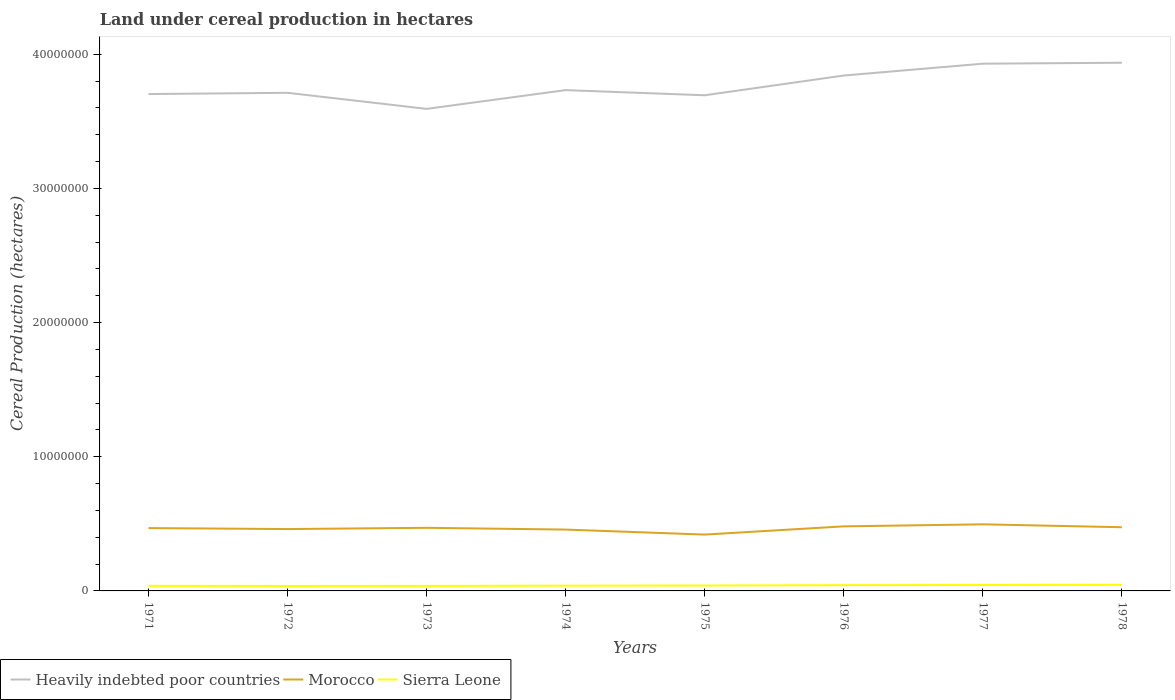Across all years, what is the maximum land under cereal production in Sierra Leone?
Make the answer very short. 3.71e+05. In which year was the land under cereal production in Heavily indebted poor countries maximum?
Offer a terse response. 1973. What is the total land under cereal production in Sierra Leone in the graph?
Your answer should be very brief. -10000. What is the difference between the highest and the second highest land under cereal production in Heavily indebted poor countries?
Provide a short and direct response. 3.44e+06. What is the difference between the highest and the lowest land under cereal production in Morocco?
Offer a very short reply. 5. How many lines are there?
Your answer should be very brief. 3. How many years are there in the graph?
Give a very brief answer. 8. What is the difference between two consecutive major ticks on the Y-axis?
Ensure brevity in your answer.  1.00e+07. Are the values on the major ticks of Y-axis written in scientific E-notation?
Provide a succinct answer. No. Does the graph contain grids?
Keep it short and to the point. No. How are the legend labels stacked?
Keep it short and to the point. Horizontal. What is the title of the graph?
Provide a short and direct response. Land under cereal production in hectares. Does "Bhutan" appear as one of the legend labels in the graph?
Your answer should be compact. No. What is the label or title of the Y-axis?
Offer a terse response. Cereal Production (hectares). What is the Cereal Production (hectares) of Heavily indebted poor countries in 1971?
Your response must be concise. 3.70e+07. What is the Cereal Production (hectares) of Morocco in 1971?
Make the answer very short. 4.68e+06. What is the Cereal Production (hectares) of Sierra Leone in 1971?
Provide a short and direct response. 3.78e+05. What is the Cereal Production (hectares) in Heavily indebted poor countries in 1972?
Provide a short and direct response. 3.71e+07. What is the Cereal Production (hectares) in Morocco in 1972?
Offer a terse response. 4.61e+06. What is the Cereal Production (hectares) of Sierra Leone in 1972?
Your response must be concise. 3.71e+05. What is the Cereal Production (hectares) in Heavily indebted poor countries in 1973?
Your response must be concise. 3.59e+07. What is the Cereal Production (hectares) in Morocco in 1973?
Keep it short and to the point. 4.70e+06. What is the Cereal Production (hectares) of Sierra Leone in 1973?
Offer a terse response. 3.74e+05. What is the Cereal Production (hectares) of Heavily indebted poor countries in 1974?
Offer a terse response. 3.73e+07. What is the Cereal Production (hectares) of Morocco in 1974?
Offer a very short reply. 4.57e+06. What is the Cereal Production (hectares) of Sierra Leone in 1974?
Your response must be concise. 3.94e+05. What is the Cereal Production (hectares) of Heavily indebted poor countries in 1975?
Your answer should be very brief. 3.69e+07. What is the Cereal Production (hectares) in Morocco in 1975?
Offer a very short reply. 4.20e+06. What is the Cereal Production (hectares) of Sierra Leone in 1975?
Provide a succinct answer. 4.04e+05. What is the Cereal Production (hectares) of Heavily indebted poor countries in 1976?
Your answer should be compact. 3.84e+07. What is the Cereal Production (hectares) of Morocco in 1976?
Ensure brevity in your answer.  4.81e+06. What is the Cereal Production (hectares) of Sierra Leone in 1976?
Ensure brevity in your answer.  4.30e+05. What is the Cereal Production (hectares) of Heavily indebted poor countries in 1977?
Provide a short and direct response. 3.93e+07. What is the Cereal Production (hectares) in Morocco in 1977?
Give a very brief answer. 4.96e+06. What is the Cereal Production (hectares) in Sierra Leone in 1977?
Make the answer very short. 4.40e+05. What is the Cereal Production (hectares) of Heavily indebted poor countries in 1978?
Your answer should be compact. 3.94e+07. What is the Cereal Production (hectares) of Morocco in 1978?
Make the answer very short. 4.75e+06. What is the Cereal Production (hectares) of Sierra Leone in 1978?
Your answer should be compact. 4.55e+05. Across all years, what is the maximum Cereal Production (hectares) in Heavily indebted poor countries?
Make the answer very short. 3.94e+07. Across all years, what is the maximum Cereal Production (hectares) in Morocco?
Offer a very short reply. 4.96e+06. Across all years, what is the maximum Cereal Production (hectares) of Sierra Leone?
Your response must be concise. 4.55e+05. Across all years, what is the minimum Cereal Production (hectares) in Heavily indebted poor countries?
Offer a terse response. 3.59e+07. Across all years, what is the minimum Cereal Production (hectares) in Morocco?
Give a very brief answer. 4.20e+06. Across all years, what is the minimum Cereal Production (hectares) in Sierra Leone?
Give a very brief answer. 3.71e+05. What is the total Cereal Production (hectares) in Heavily indebted poor countries in the graph?
Provide a short and direct response. 3.01e+08. What is the total Cereal Production (hectares) in Morocco in the graph?
Your answer should be compact. 3.73e+07. What is the total Cereal Production (hectares) of Sierra Leone in the graph?
Your answer should be very brief. 3.25e+06. What is the difference between the Cereal Production (hectares) of Heavily indebted poor countries in 1971 and that in 1972?
Offer a terse response. -9.20e+04. What is the difference between the Cereal Production (hectares) in Morocco in 1971 and that in 1972?
Keep it short and to the point. 7.42e+04. What is the difference between the Cereal Production (hectares) of Sierra Leone in 1971 and that in 1972?
Your answer should be very brief. 7800. What is the difference between the Cereal Production (hectares) of Heavily indebted poor countries in 1971 and that in 1973?
Provide a succinct answer. 1.10e+06. What is the difference between the Cereal Production (hectares) of Morocco in 1971 and that in 1973?
Your answer should be compact. -1.99e+04. What is the difference between the Cereal Production (hectares) in Sierra Leone in 1971 and that in 1973?
Offer a terse response. 4700. What is the difference between the Cereal Production (hectares) in Heavily indebted poor countries in 1971 and that in 1974?
Your answer should be compact. -2.92e+05. What is the difference between the Cereal Production (hectares) of Morocco in 1971 and that in 1974?
Offer a very short reply. 1.12e+05. What is the difference between the Cereal Production (hectares) in Sierra Leone in 1971 and that in 1974?
Offer a terse response. -1.51e+04. What is the difference between the Cereal Production (hectares) in Heavily indebted poor countries in 1971 and that in 1975?
Provide a short and direct response. 9.14e+04. What is the difference between the Cereal Production (hectares) of Morocco in 1971 and that in 1975?
Your response must be concise. 4.84e+05. What is the difference between the Cereal Production (hectares) of Sierra Leone in 1971 and that in 1975?
Provide a short and direct response. -2.51e+04. What is the difference between the Cereal Production (hectares) in Heavily indebted poor countries in 1971 and that in 1976?
Give a very brief answer. -1.38e+06. What is the difference between the Cereal Production (hectares) of Morocco in 1971 and that in 1976?
Your answer should be compact. -1.28e+05. What is the difference between the Cereal Production (hectares) of Sierra Leone in 1971 and that in 1976?
Your response must be concise. -5.14e+04. What is the difference between the Cereal Production (hectares) in Heavily indebted poor countries in 1971 and that in 1977?
Ensure brevity in your answer.  -2.26e+06. What is the difference between the Cereal Production (hectares) of Morocco in 1971 and that in 1977?
Ensure brevity in your answer.  -2.79e+05. What is the difference between the Cereal Production (hectares) of Sierra Leone in 1971 and that in 1977?
Your answer should be very brief. -6.20e+04. What is the difference between the Cereal Production (hectares) of Heavily indebted poor countries in 1971 and that in 1978?
Ensure brevity in your answer.  -2.33e+06. What is the difference between the Cereal Production (hectares) of Morocco in 1971 and that in 1978?
Offer a very short reply. -6.35e+04. What is the difference between the Cereal Production (hectares) in Sierra Leone in 1971 and that in 1978?
Give a very brief answer. -7.70e+04. What is the difference between the Cereal Production (hectares) in Heavily indebted poor countries in 1972 and that in 1973?
Keep it short and to the point. 1.20e+06. What is the difference between the Cereal Production (hectares) of Morocco in 1972 and that in 1973?
Provide a short and direct response. -9.41e+04. What is the difference between the Cereal Production (hectares) in Sierra Leone in 1972 and that in 1973?
Keep it short and to the point. -3100. What is the difference between the Cereal Production (hectares) in Heavily indebted poor countries in 1972 and that in 1974?
Make the answer very short. -2.00e+05. What is the difference between the Cereal Production (hectares) of Morocco in 1972 and that in 1974?
Make the answer very short. 3.81e+04. What is the difference between the Cereal Production (hectares) in Sierra Leone in 1972 and that in 1974?
Provide a succinct answer. -2.29e+04. What is the difference between the Cereal Production (hectares) of Heavily indebted poor countries in 1972 and that in 1975?
Your answer should be very brief. 1.83e+05. What is the difference between the Cereal Production (hectares) in Morocco in 1972 and that in 1975?
Keep it short and to the point. 4.10e+05. What is the difference between the Cereal Production (hectares) in Sierra Leone in 1972 and that in 1975?
Give a very brief answer. -3.29e+04. What is the difference between the Cereal Production (hectares) in Heavily indebted poor countries in 1972 and that in 1976?
Keep it short and to the point. -1.29e+06. What is the difference between the Cereal Production (hectares) in Morocco in 1972 and that in 1976?
Ensure brevity in your answer.  -2.02e+05. What is the difference between the Cereal Production (hectares) of Sierra Leone in 1972 and that in 1976?
Offer a very short reply. -5.92e+04. What is the difference between the Cereal Production (hectares) in Heavily indebted poor countries in 1972 and that in 1977?
Offer a very short reply. -2.17e+06. What is the difference between the Cereal Production (hectares) in Morocco in 1972 and that in 1977?
Your answer should be very brief. -3.53e+05. What is the difference between the Cereal Production (hectares) of Sierra Leone in 1972 and that in 1977?
Provide a short and direct response. -6.98e+04. What is the difference between the Cereal Production (hectares) in Heavily indebted poor countries in 1972 and that in 1978?
Your answer should be compact. -2.24e+06. What is the difference between the Cereal Production (hectares) of Morocco in 1972 and that in 1978?
Offer a very short reply. -1.38e+05. What is the difference between the Cereal Production (hectares) of Sierra Leone in 1972 and that in 1978?
Provide a short and direct response. -8.48e+04. What is the difference between the Cereal Production (hectares) of Heavily indebted poor countries in 1973 and that in 1974?
Make the answer very short. -1.40e+06. What is the difference between the Cereal Production (hectares) in Morocco in 1973 and that in 1974?
Your response must be concise. 1.32e+05. What is the difference between the Cereal Production (hectares) in Sierra Leone in 1973 and that in 1974?
Offer a very short reply. -1.98e+04. What is the difference between the Cereal Production (hectares) in Heavily indebted poor countries in 1973 and that in 1975?
Provide a succinct answer. -1.01e+06. What is the difference between the Cereal Production (hectares) in Morocco in 1973 and that in 1975?
Keep it short and to the point. 5.04e+05. What is the difference between the Cereal Production (hectares) in Sierra Leone in 1973 and that in 1975?
Make the answer very short. -2.98e+04. What is the difference between the Cereal Production (hectares) of Heavily indebted poor countries in 1973 and that in 1976?
Offer a very short reply. -2.48e+06. What is the difference between the Cereal Production (hectares) of Morocco in 1973 and that in 1976?
Provide a succinct answer. -1.08e+05. What is the difference between the Cereal Production (hectares) of Sierra Leone in 1973 and that in 1976?
Give a very brief answer. -5.61e+04. What is the difference between the Cereal Production (hectares) in Heavily indebted poor countries in 1973 and that in 1977?
Your response must be concise. -3.37e+06. What is the difference between the Cereal Production (hectares) in Morocco in 1973 and that in 1977?
Keep it short and to the point. -2.59e+05. What is the difference between the Cereal Production (hectares) of Sierra Leone in 1973 and that in 1977?
Offer a very short reply. -6.67e+04. What is the difference between the Cereal Production (hectares) in Heavily indebted poor countries in 1973 and that in 1978?
Provide a succinct answer. -3.44e+06. What is the difference between the Cereal Production (hectares) of Morocco in 1973 and that in 1978?
Your answer should be compact. -4.36e+04. What is the difference between the Cereal Production (hectares) of Sierra Leone in 1973 and that in 1978?
Your response must be concise. -8.17e+04. What is the difference between the Cereal Production (hectares) in Heavily indebted poor countries in 1974 and that in 1975?
Offer a very short reply. 3.83e+05. What is the difference between the Cereal Production (hectares) of Morocco in 1974 and that in 1975?
Your answer should be compact. 3.72e+05. What is the difference between the Cereal Production (hectares) in Sierra Leone in 1974 and that in 1975?
Your response must be concise. -10000. What is the difference between the Cereal Production (hectares) in Heavily indebted poor countries in 1974 and that in 1976?
Keep it short and to the point. -1.09e+06. What is the difference between the Cereal Production (hectares) of Morocco in 1974 and that in 1976?
Your answer should be very brief. -2.40e+05. What is the difference between the Cereal Production (hectares) of Sierra Leone in 1974 and that in 1976?
Your answer should be compact. -3.63e+04. What is the difference between the Cereal Production (hectares) of Heavily indebted poor countries in 1974 and that in 1977?
Your response must be concise. -1.97e+06. What is the difference between the Cereal Production (hectares) in Morocco in 1974 and that in 1977?
Ensure brevity in your answer.  -3.91e+05. What is the difference between the Cereal Production (hectares) of Sierra Leone in 1974 and that in 1977?
Your response must be concise. -4.69e+04. What is the difference between the Cereal Production (hectares) in Heavily indebted poor countries in 1974 and that in 1978?
Provide a short and direct response. -2.04e+06. What is the difference between the Cereal Production (hectares) in Morocco in 1974 and that in 1978?
Your answer should be very brief. -1.76e+05. What is the difference between the Cereal Production (hectares) of Sierra Leone in 1974 and that in 1978?
Provide a short and direct response. -6.19e+04. What is the difference between the Cereal Production (hectares) in Heavily indebted poor countries in 1975 and that in 1976?
Provide a short and direct response. -1.47e+06. What is the difference between the Cereal Production (hectares) of Morocco in 1975 and that in 1976?
Your response must be concise. -6.12e+05. What is the difference between the Cereal Production (hectares) of Sierra Leone in 1975 and that in 1976?
Provide a succinct answer. -2.63e+04. What is the difference between the Cereal Production (hectares) of Heavily indebted poor countries in 1975 and that in 1977?
Your answer should be very brief. -2.35e+06. What is the difference between the Cereal Production (hectares) in Morocco in 1975 and that in 1977?
Provide a succinct answer. -7.63e+05. What is the difference between the Cereal Production (hectares) in Sierra Leone in 1975 and that in 1977?
Your answer should be very brief. -3.69e+04. What is the difference between the Cereal Production (hectares) in Heavily indebted poor countries in 1975 and that in 1978?
Provide a succinct answer. -2.42e+06. What is the difference between the Cereal Production (hectares) in Morocco in 1975 and that in 1978?
Your response must be concise. -5.48e+05. What is the difference between the Cereal Production (hectares) in Sierra Leone in 1975 and that in 1978?
Provide a short and direct response. -5.19e+04. What is the difference between the Cereal Production (hectares) in Heavily indebted poor countries in 1976 and that in 1977?
Give a very brief answer. -8.82e+05. What is the difference between the Cereal Production (hectares) in Morocco in 1976 and that in 1977?
Offer a terse response. -1.51e+05. What is the difference between the Cereal Production (hectares) of Sierra Leone in 1976 and that in 1977?
Your response must be concise. -1.06e+04. What is the difference between the Cereal Production (hectares) of Heavily indebted poor countries in 1976 and that in 1978?
Keep it short and to the point. -9.54e+05. What is the difference between the Cereal Production (hectares) in Morocco in 1976 and that in 1978?
Provide a succinct answer. 6.41e+04. What is the difference between the Cereal Production (hectares) of Sierra Leone in 1976 and that in 1978?
Provide a short and direct response. -2.56e+04. What is the difference between the Cereal Production (hectares) in Heavily indebted poor countries in 1977 and that in 1978?
Your response must be concise. -7.14e+04. What is the difference between the Cereal Production (hectares) in Morocco in 1977 and that in 1978?
Your answer should be very brief. 2.16e+05. What is the difference between the Cereal Production (hectares) of Sierra Leone in 1977 and that in 1978?
Offer a terse response. -1.50e+04. What is the difference between the Cereal Production (hectares) in Heavily indebted poor countries in 1971 and the Cereal Production (hectares) in Morocco in 1972?
Provide a short and direct response. 3.24e+07. What is the difference between the Cereal Production (hectares) in Heavily indebted poor countries in 1971 and the Cereal Production (hectares) in Sierra Leone in 1972?
Your answer should be very brief. 3.67e+07. What is the difference between the Cereal Production (hectares) in Morocco in 1971 and the Cereal Production (hectares) in Sierra Leone in 1972?
Your answer should be very brief. 4.31e+06. What is the difference between the Cereal Production (hectares) in Heavily indebted poor countries in 1971 and the Cereal Production (hectares) in Morocco in 1973?
Offer a very short reply. 3.23e+07. What is the difference between the Cereal Production (hectares) of Heavily indebted poor countries in 1971 and the Cereal Production (hectares) of Sierra Leone in 1973?
Give a very brief answer. 3.67e+07. What is the difference between the Cereal Production (hectares) of Morocco in 1971 and the Cereal Production (hectares) of Sierra Leone in 1973?
Provide a short and direct response. 4.31e+06. What is the difference between the Cereal Production (hectares) of Heavily indebted poor countries in 1971 and the Cereal Production (hectares) of Morocco in 1974?
Your answer should be compact. 3.25e+07. What is the difference between the Cereal Production (hectares) in Heavily indebted poor countries in 1971 and the Cereal Production (hectares) in Sierra Leone in 1974?
Keep it short and to the point. 3.66e+07. What is the difference between the Cereal Production (hectares) in Morocco in 1971 and the Cereal Production (hectares) in Sierra Leone in 1974?
Make the answer very short. 4.29e+06. What is the difference between the Cereal Production (hectares) in Heavily indebted poor countries in 1971 and the Cereal Production (hectares) in Morocco in 1975?
Ensure brevity in your answer.  3.28e+07. What is the difference between the Cereal Production (hectares) in Heavily indebted poor countries in 1971 and the Cereal Production (hectares) in Sierra Leone in 1975?
Your answer should be compact. 3.66e+07. What is the difference between the Cereal Production (hectares) in Morocco in 1971 and the Cereal Production (hectares) in Sierra Leone in 1975?
Provide a short and direct response. 4.28e+06. What is the difference between the Cereal Production (hectares) of Heavily indebted poor countries in 1971 and the Cereal Production (hectares) of Morocco in 1976?
Offer a very short reply. 3.22e+07. What is the difference between the Cereal Production (hectares) in Heavily indebted poor countries in 1971 and the Cereal Production (hectares) in Sierra Leone in 1976?
Provide a succinct answer. 3.66e+07. What is the difference between the Cereal Production (hectares) of Morocco in 1971 and the Cereal Production (hectares) of Sierra Leone in 1976?
Ensure brevity in your answer.  4.25e+06. What is the difference between the Cereal Production (hectares) of Heavily indebted poor countries in 1971 and the Cereal Production (hectares) of Morocco in 1977?
Offer a very short reply. 3.21e+07. What is the difference between the Cereal Production (hectares) in Heavily indebted poor countries in 1971 and the Cereal Production (hectares) in Sierra Leone in 1977?
Ensure brevity in your answer.  3.66e+07. What is the difference between the Cereal Production (hectares) in Morocco in 1971 and the Cereal Production (hectares) in Sierra Leone in 1977?
Give a very brief answer. 4.24e+06. What is the difference between the Cereal Production (hectares) in Heavily indebted poor countries in 1971 and the Cereal Production (hectares) in Morocco in 1978?
Give a very brief answer. 3.23e+07. What is the difference between the Cereal Production (hectares) of Heavily indebted poor countries in 1971 and the Cereal Production (hectares) of Sierra Leone in 1978?
Ensure brevity in your answer.  3.66e+07. What is the difference between the Cereal Production (hectares) in Morocco in 1971 and the Cereal Production (hectares) in Sierra Leone in 1978?
Provide a short and direct response. 4.23e+06. What is the difference between the Cereal Production (hectares) in Heavily indebted poor countries in 1972 and the Cereal Production (hectares) in Morocco in 1973?
Provide a succinct answer. 3.24e+07. What is the difference between the Cereal Production (hectares) of Heavily indebted poor countries in 1972 and the Cereal Production (hectares) of Sierra Leone in 1973?
Give a very brief answer. 3.68e+07. What is the difference between the Cereal Production (hectares) in Morocco in 1972 and the Cereal Production (hectares) in Sierra Leone in 1973?
Your answer should be compact. 4.24e+06. What is the difference between the Cereal Production (hectares) of Heavily indebted poor countries in 1972 and the Cereal Production (hectares) of Morocco in 1974?
Offer a very short reply. 3.26e+07. What is the difference between the Cereal Production (hectares) of Heavily indebted poor countries in 1972 and the Cereal Production (hectares) of Sierra Leone in 1974?
Ensure brevity in your answer.  3.67e+07. What is the difference between the Cereal Production (hectares) in Morocco in 1972 and the Cereal Production (hectares) in Sierra Leone in 1974?
Offer a terse response. 4.22e+06. What is the difference between the Cereal Production (hectares) of Heavily indebted poor countries in 1972 and the Cereal Production (hectares) of Morocco in 1975?
Your answer should be compact. 3.29e+07. What is the difference between the Cereal Production (hectares) in Heavily indebted poor countries in 1972 and the Cereal Production (hectares) in Sierra Leone in 1975?
Offer a terse response. 3.67e+07. What is the difference between the Cereal Production (hectares) in Morocco in 1972 and the Cereal Production (hectares) in Sierra Leone in 1975?
Your response must be concise. 4.21e+06. What is the difference between the Cereal Production (hectares) of Heavily indebted poor countries in 1972 and the Cereal Production (hectares) of Morocco in 1976?
Offer a very short reply. 3.23e+07. What is the difference between the Cereal Production (hectares) of Heavily indebted poor countries in 1972 and the Cereal Production (hectares) of Sierra Leone in 1976?
Keep it short and to the point. 3.67e+07. What is the difference between the Cereal Production (hectares) of Morocco in 1972 and the Cereal Production (hectares) of Sierra Leone in 1976?
Keep it short and to the point. 4.18e+06. What is the difference between the Cereal Production (hectares) of Heavily indebted poor countries in 1972 and the Cereal Production (hectares) of Morocco in 1977?
Your answer should be very brief. 3.22e+07. What is the difference between the Cereal Production (hectares) in Heavily indebted poor countries in 1972 and the Cereal Production (hectares) in Sierra Leone in 1977?
Ensure brevity in your answer.  3.67e+07. What is the difference between the Cereal Production (hectares) in Morocco in 1972 and the Cereal Production (hectares) in Sierra Leone in 1977?
Offer a terse response. 4.17e+06. What is the difference between the Cereal Production (hectares) of Heavily indebted poor countries in 1972 and the Cereal Production (hectares) of Morocco in 1978?
Your answer should be very brief. 3.24e+07. What is the difference between the Cereal Production (hectares) in Heavily indebted poor countries in 1972 and the Cereal Production (hectares) in Sierra Leone in 1978?
Provide a succinct answer. 3.67e+07. What is the difference between the Cereal Production (hectares) of Morocco in 1972 and the Cereal Production (hectares) of Sierra Leone in 1978?
Offer a very short reply. 4.15e+06. What is the difference between the Cereal Production (hectares) of Heavily indebted poor countries in 1973 and the Cereal Production (hectares) of Morocco in 1974?
Make the answer very short. 3.14e+07. What is the difference between the Cereal Production (hectares) in Heavily indebted poor countries in 1973 and the Cereal Production (hectares) in Sierra Leone in 1974?
Give a very brief answer. 3.55e+07. What is the difference between the Cereal Production (hectares) of Morocco in 1973 and the Cereal Production (hectares) of Sierra Leone in 1974?
Keep it short and to the point. 4.31e+06. What is the difference between the Cereal Production (hectares) in Heavily indebted poor countries in 1973 and the Cereal Production (hectares) in Morocco in 1975?
Provide a succinct answer. 3.17e+07. What is the difference between the Cereal Production (hectares) of Heavily indebted poor countries in 1973 and the Cereal Production (hectares) of Sierra Leone in 1975?
Offer a terse response. 3.55e+07. What is the difference between the Cereal Production (hectares) in Morocco in 1973 and the Cereal Production (hectares) in Sierra Leone in 1975?
Keep it short and to the point. 4.30e+06. What is the difference between the Cereal Production (hectares) in Heavily indebted poor countries in 1973 and the Cereal Production (hectares) in Morocco in 1976?
Your answer should be compact. 3.11e+07. What is the difference between the Cereal Production (hectares) of Heavily indebted poor countries in 1973 and the Cereal Production (hectares) of Sierra Leone in 1976?
Keep it short and to the point. 3.55e+07. What is the difference between the Cereal Production (hectares) in Morocco in 1973 and the Cereal Production (hectares) in Sierra Leone in 1976?
Provide a short and direct response. 4.27e+06. What is the difference between the Cereal Production (hectares) in Heavily indebted poor countries in 1973 and the Cereal Production (hectares) in Morocco in 1977?
Keep it short and to the point. 3.10e+07. What is the difference between the Cereal Production (hectares) of Heavily indebted poor countries in 1973 and the Cereal Production (hectares) of Sierra Leone in 1977?
Your answer should be compact. 3.55e+07. What is the difference between the Cereal Production (hectares) in Morocco in 1973 and the Cereal Production (hectares) in Sierra Leone in 1977?
Ensure brevity in your answer.  4.26e+06. What is the difference between the Cereal Production (hectares) of Heavily indebted poor countries in 1973 and the Cereal Production (hectares) of Morocco in 1978?
Provide a short and direct response. 3.12e+07. What is the difference between the Cereal Production (hectares) of Heavily indebted poor countries in 1973 and the Cereal Production (hectares) of Sierra Leone in 1978?
Ensure brevity in your answer.  3.55e+07. What is the difference between the Cereal Production (hectares) of Morocco in 1973 and the Cereal Production (hectares) of Sierra Leone in 1978?
Offer a very short reply. 4.25e+06. What is the difference between the Cereal Production (hectares) of Heavily indebted poor countries in 1974 and the Cereal Production (hectares) of Morocco in 1975?
Your answer should be compact. 3.31e+07. What is the difference between the Cereal Production (hectares) of Heavily indebted poor countries in 1974 and the Cereal Production (hectares) of Sierra Leone in 1975?
Provide a short and direct response. 3.69e+07. What is the difference between the Cereal Production (hectares) of Morocco in 1974 and the Cereal Production (hectares) of Sierra Leone in 1975?
Your response must be concise. 4.17e+06. What is the difference between the Cereal Production (hectares) of Heavily indebted poor countries in 1974 and the Cereal Production (hectares) of Morocco in 1976?
Your answer should be compact. 3.25e+07. What is the difference between the Cereal Production (hectares) of Heavily indebted poor countries in 1974 and the Cereal Production (hectares) of Sierra Leone in 1976?
Provide a short and direct response. 3.69e+07. What is the difference between the Cereal Production (hectares) of Morocco in 1974 and the Cereal Production (hectares) of Sierra Leone in 1976?
Your answer should be compact. 4.14e+06. What is the difference between the Cereal Production (hectares) of Heavily indebted poor countries in 1974 and the Cereal Production (hectares) of Morocco in 1977?
Ensure brevity in your answer.  3.24e+07. What is the difference between the Cereal Production (hectares) of Heavily indebted poor countries in 1974 and the Cereal Production (hectares) of Sierra Leone in 1977?
Provide a succinct answer. 3.69e+07. What is the difference between the Cereal Production (hectares) of Morocco in 1974 and the Cereal Production (hectares) of Sierra Leone in 1977?
Offer a very short reply. 4.13e+06. What is the difference between the Cereal Production (hectares) in Heavily indebted poor countries in 1974 and the Cereal Production (hectares) in Morocco in 1978?
Provide a succinct answer. 3.26e+07. What is the difference between the Cereal Production (hectares) in Heavily indebted poor countries in 1974 and the Cereal Production (hectares) in Sierra Leone in 1978?
Provide a short and direct response. 3.69e+07. What is the difference between the Cereal Production (hectares) of Morocco in 1974 and the Cereal Production (hectares) of Sierra Leone in 1978?
Give a very brief answer. 4.12e+06. What is the difference between the Cereal Production (hectares) in Heavily indebted poor countries in 1975 and the Cereal Production (hectares) in Morocco in 1976?
Your answer should be compact. 3.21e+07. What is the difference between the Cereal Production (hectares) of Heavily indebted poor countries in 1975 and the Cereal Production (hectares) of Sierra Leone in 1976?
Offer a very short reply. 3.65e+07. What is the difference between the Cereal Production (hectares) of Morocco in 1975 and the Cereal Production (hectares) of Sierra Leone in 1976?
Make the answer very short. 3.77e+06. What is the difference between the Cereal Production (hectares) of Heavily indebted poor countries in 1975 and the Cereal Production (hectares) of Morocco in 1977?
Provide a short and direct response. 3.20e+07. What is the difference between the Cereal Production (hectares) of Heavily indebted poor countries in 1975 and the Cereal Production (hectares) of Sierra Leone in 1977?
Give a very brief answer. 3.65e+07. What is the difference between the Cereal Production (hectares) of Morocco in 1975 and the Cereal Production (hectares) of Sierra Leone in 1977?
Your answer should be very brief. 3.76e+06. What is the difference between the Cereal Production (hectares) in Heavily indebted poor countries in 1975 and the Cereal Production (hectares) in Morocco in 1978?
Ensure brevity in your answer.  3.22e+07. What is the difference between the Cereal Production (hectares) of Heavily indebted poor countries in 1975 and the Cereal Production (hectares) of Sierra Leone in 1978?
Offer a very short reply. 3.65e+07. What is the difference between the Cereal Production (hectares) of Morocco in 1975 and the Cereal Production (hectares) of Sierra Leone in 1978?
Provide a short and direct response. 3.74e+06. What is the difference between the Cereal Production (hectares) in Heavily indebted poor countries in 1976 and the Cereal Production (hectares) in Morocco in 1977?
Your answer should be very brief. 3.35e+07. What is the difference between the Cereal Production (hectares) of Heavily indebted poor countries in 1976 and the Cereal Production (hectares) of Sierra Leone in 1977?
Offer a terse response. 3.80e+07. What is the difference between the Cereal Production (hectares) of Morocco in 1976 and the Cereal Production (hectares) of Sierra Leone in 1977?
Offer a very short reply. 4.37e+06. What is the difference between the Cereal Production (hectares) of Heavily indebted poor countries in 1976 and the Cereal Production (hectares) of Morocco in 1978?
Offer a terse response. 3.37e+07. What is the difference between the Cereal Production (hectares) in Heavily indebted poor countries in 1976 and the Cereal Production (hectares) in Sierra Leone in 1978?
Ensure brevity in your answer.  3.80e+07. What is the difference between the Cereal Production (hectares) in Morocco in 1976 and the Cereal Production (hectares) in Sierra Leone in 1978?
Provide a short and direct response. 4.36e+06. What is the difference between the Cereal Production (hectares) in Heavily indebted poor countries in 1977 and the Cereal Production (hectares) in Morocco in 1978?
Your answer should be compact. 3.45e+07. What is the difference between the Cereal Production (hectares) of Heavily indebted poor countries in 1977 and the Cereal Production (hectares) of Sierra Leone in 1978?
Provide a succinct answer. 3.88e+07. What is the difference between the Cereal Production (hectares) of Morocco in 1977 and the Cereal Production (hectares) of Sierra Leone in 1978?
Give a very brief answer. 4.51e+06. What is the average Cereal Production (hectares) of Heavily indebted poor countries per year?
Your answer should be compact. 3.77e+07. What is the average Cereal Production (hectares) in Morocco per year?
Your answer should be compact. 4.66e+06. What is the average Cereal Production (hectares) in Sierra Leone per year?
Give a very brief answer. 4.06e+05. In the year 1971, what is the difference between the Cereal Production (hectares) in Heavily indebted poor countries and Cereal Production (hectares) in Morocco?
Your answer should be compact. 3.24e+07. In the year 1971, what is the difference between the Cereal Production (hectares) in Heavily indebted poor countries and Cereal Production (hectares) in Sierra Leone?
Offer a very short reply. 3.67e+07. In the year 1971, what is the difference between the Cereal Production (hectares) of Morocco and Cereal Production (hectares) of Sierra Leone?
Your answer should be very brief. 4.31e+06. In the year 1972, what is the difference between the Cereal Production (hectares) of Heavily indebted poor countries and Cereal Production (hectares) of Morocco?
Offer a very short reply. 3.25e+07. In the year 1972, what is the difference between the Cereal Production (hectares) of Heavily indebted poor countries and Cereal Production (hectares) of Sierra Leone?
Provide a short and direct response. 3.68e+07. In the year 1972, what is the difference between the Cereal Production (hectares) of Morocco and Cereal Production (hectares) of Sierra Leone?
Your response must be concise. 4.24e+06. In the year 1973, what is the difference between the Cereal Production (hectares) in Heavily indebted poor countries and Cereal Production (hectares) in Morocco?
Offer a terse response. 3.12e+07. In the year 1973, what is the difference between the Cereal Production (hectares) of Heavily indebted poor countries and Cereal Production (hectares) of Sierra Leone?
Offer a very short reply. 3.56e+07. In the year 1973, what is the difference between the Cereal Production (hectares) in Morocco and Cereal Production (hectares) in Sierra Leone?
Offer a terse response. 4.33e+06. In the year 1974, what is the difference between the Cereal Production (hectares) of Heavily indebted poor countries and Cereal Production (hectares) of Morocco?
Your answer should be compact. 3.28e+07. In the year 1974, what is the difference between the Cereal Production (hectares) in Heavily indebted poor countries and Cereal Production (hectares) in Sierra Leone?
Offer a very short reply. 3.69e+07. In the year 1974, what is the difference between the Cereal Production (hectares) of Morocco and Cereal Production (hectares) of Sierra Leone?
Your answer should be compact. 4.18e+06. In the year 1975, what is the difference between the Cereal Production (hectares) in Heavily indebted poor countries and Cereal Production (hectares) in Morocco?
Ensure brevity in your answer.  3.27e+07. In the year 1975, what is the difference between the Cereal Production (hectares) in Heavily indebted poor countries and Cereal Production (hectares) in Sierra Leone?
Make the answer very short. 3.65e+07. In the year 1975, what is the difference between the Cereal Production (hectares) of Morocco and Cereal Production (hectares) of Sierra Leone?
Provide a short and direct response. 3.80e+06. In the year 1976, what is the difference between the Cereal Production (hectares) in Heavily indebted poor countries and Cereal Production (hectares) in Morocco?
Your answer should be very brief. 3.36e+07. In the year 1976, what is the difference between the Cereal Production (hectares) in Heavily indebted poor countries and Cereal Production (hectares) in Sierra Leone?
Offer a very short reply. 3.80e+07. In the year 1976, what is the difference between the Cereal Production (hectares) of Morocco and Cereal Production (hectares) of Sierra Leone?
Offer a terse response. 4.38e+06. In the year 1977, what is the difference between the Cereal Production (hectares) of Heavily indebted poor countries and Cereal Production (hectares) of Morocco?
Offer a very short reply. 3.43e+07. In the year 1977, what is the difference between the Cereal Production (hectares) in Heavily indebted poor countries and Cereal Production (hectares) in Sierra Leone?
Make the answer very short. 3.89e+07. In the year 1977, what is the difference between the Cereal Production (hectares) in Morocco and Cereal Production (hectares) in Sierra Leone?
Provide a short and direct response. 4.52e+06. In the year 1978, what is the difference between the Cereal Production (hectares) in Heavily indebted poor countries and Cereal Production (hectares) in Morocco?
Your response must be concise. 3.46e+07. In the year 1978, what is the difference between the Cereal Production (hectares) in Heavily indebted poor countries and Cereal Production (hectares) in Sierra Leone?
Keep it short and to the point. 3.89e+07. In the year 1978, what is the difference between the Cereal Production (hectares) of Morocco and Cereal Production (hectares) of Sierra Leone?
Your answer should be compact. 4.29e+06. What is the ratio of the Cereal Production (hectares) in Morocco in 1971 to that in 1972?
Your answer should be very brief. 1.02. What is the ratio of the Cereal Production (hectares) of Sierra Leone in 1971 to that in 1972?
Keep it short and to the point. 1.02. What is the ratio of the Cereal Production (hectares) of Heavily indebted poor countries in 1971 to that in 1973?
Provide a succinct answer. 1.03. What is the ratio of the Cereal Production (hectares) of Sierra Leone in 1971 to that in 1973?
Offer a terse response. 1.01. What is the ratio of the Cereal Production (hectares) of Heavily indebted poor countries in 1971 to that in 1974?
Ensure brevity in your answer.  0.99. What is the ratio of the Cereal Production (hectares) in Morocco in 1971 to that in 1974?
Offer a very short reply. 1.02. What is the ratio of the Cereal Production (hectares) in Sierra Leone in 1971 to that in 1974?
Keep it short and to the point. 0.96. What is the ratio of the Cereal Production (hectares) in Morocco in 1971 to that in 1975?
Offer a very short reply. 1.12. What is the ratio of the Cereal Production (hectares) of Sierra Leone in 1971 to that in 1975?
Make the answer very short. 0.94. What is the ratio of the Cereal Production (hectares) in Heavily indebted poor countries in 1971 to that in 1976?
Offer a very short reply. 0.96. What is the ratio of the Cereal Production (hectares) of Morocco in 1971 to that in 1976?
Offer a terse response. 0.97. What is the ratio of the Cereal Production (hectares) in Sierra Leone in 1971 to that in 1976?
Offer a very short reply. 0.88. What is the ratio of the Cereal Production (hectares) of Heavily indebted poor countries in 1971 to that in 1977?
Provide a succinct answer. 0.94. What is the ratio of the Cereal Production (hectares) of Morocco in 1971 to that in 1977?
Give a very brief answer. 0.94. What is the ratio of the Cereal Production (hectares) in Sierra Leone in 1971 to that in 1977?
Make the answer very short. 0.86. What is the ratio of the Cereal Production (hectares) of Heavily indebted poor countries in 1971 to that in 1978?
Ensure brevity in your answer.  0.94. What is the ratio of the Cereal Production (hectares) in Morocco in 1971 to that in 1978?
Offer a very short reply. 0.99. What is the ratio of the Cereal Production (hectares) of Sierra Leone in 1971 to that in 1978?
Your answer should be very brief. 0.83. What is the ratio of the Cereal Production (hectares) in Heavily indebted poor countries in 1972 to that in 1973?
Your answer should be very brief. 1.03. What is the ratio of the Cereal Production (hectares) in Morocco in 1972 to that in 1974?
Offer a very short reply. 1.01. What is the ratio of the Cereal Production (hectares) in Sierra Leone in 1972 to that in 1974?
Offer a very short reply. 0.94. What is the ratio of the Cereal Production (hectares) of Heavily indebted poor countries in 1972 to that in 1975?
Keep it short and to the point. 1. What is the ratio of the Cereal Production (hectares) in Morocco in 1972 to that in 1975?
Make the answer very short. 1.1. What is the ratio of the Cereal Production (hectares) of Sierra Leone in 1972 to that in 1975?
Provide a succinct answer. 0.92. What is the ratio of the Cereal Production (hectares) in Heavily indebted poor countries in 1972 to that in 1976?
Make the answer very short. 0.97. What is the ratio of the Cereal Production (hectares) in Morocco in 1972 to that in 1976?
Your answer should be very brief. 0.96. What is the ratio of the Cereal Production (hectares) of Sierra Leone in 1972 to that in 1976?
Keep it short and to the point. 0.86. What is the ratio of the Cereal Production (hectares) of Heavily indebted poor countries in 1972 to that in 1977?
Ensure brevity in your answer.  0.94. What is the ratio of the Cereal Production (hectares) in Morocco in 1972 to that in 1977?
Your answer should be compact. 0.93. What is the ratio of the Cereal Production (hectares) of Sierra Leone in 1972 to that in 1977?
Offer a terse response. 0.84. What is the ratio of the Cereal Production (hectares) in Heavily indebted poor countries in 1972 to that in 1978?
Make the answer very short. 0.94. What is the ratio of the Cereal Production (hectares) of Sierra Leone in 1972 to that in 1978?
Ensure brevity in your answer.  0.81. What is the ratio of the Cereal Production (hectares) of Heavily indebted poor countries in 1973 to that in 1974?
Your answer should be very brief. 0.96. What is the ratio of the Cereal Production (hectares) in Morocco in 1973 to that in 1974?
Your response must be concise. 1.03. What is the ratio of the Cereal Production (hectares) of Sierra Leone in 1973 to that in 1974?
Offer a terse response. 0.95. What is the ratio of the Cereal Production (hectares) in Heavily indebted poor countries in 1973 to that in 1975?
Provide a succinct answer. 0.97. What is the ratio of the Cereal Production (hectares) in Morocco in 1973 to that in 1975?
Your response must be concise. 1.12. What is the ratio of the Cereal Production (hectares) in Sierra Leone in 1973 to that in 1975?
Offer a terse response. 0.93. What is the ratio of the Cereal Production (hectares) in Heavily indebted poor countries in 1973 to that in 1976?
Give a very brief answer. 0.94. What is the ratio of the Cereal Production (hectares) in Morocco in 1973 to that in 1976?
Ensure brevity in your answer.  0.98. What is the ratio of the Cereal Production (hectares) in Sierra Leone in 1973 to that in 1976?
Keep it short and to the point. 0.87. What is the ratio of the Cereal Production (hectares) of Heavily indebted poor countries in 1973 to that in 1977?
Offer a very short reply. 0.91. What is the ratio of the Cereal Production (hectares) of Morocco in 1973 to that in 1977?
Provide a short and direct response. 0.95. What is the ratio of the Cereal Production (hectares) of Sierra Leone in 1973 to that in 1977?
Offer a terse response. 0.85. What is the ratio of the Cereal Production (hectares) of Heavily indebted poor countries in 1973 to that in 1978?
Provide a short and direct response. 0.91. What is the ratio of the Cereal Production (hectares) in Sierra Leone in 1973 to that in 1978?
Keep it short and to the point. 0.82. What is the ratio of the Cereal Production (hectares) of Heavily indebted poor countries in 1974 to that in 1975?
Your answer should be very brief. 1.01. What is the ratio of the Cereal Production (hectares) in Morocco in 1974 to that in 1975?
Provide a short and direct response. 1.09. What is the ratio of the Cereal Production (hectares) of Sierra Leone in 1974 to that in 1975?
Provide a short and direct response. 0.98. What is the ratio of the Cereal Production (hectares) of Heavily indebted poor countries in 1974 to that in 1976?
Your answer should be very brief. 0.97. What is the ratio of the Cereal Production (hectares) of Morocco in 1974 to that in 1976?
Provide a short and direct response. 0.95. What is the ratio of the Cereal Production (hectares) in Sierra Leone in 1974 to that in 1976?
Give a very brief answer. 0.92. What is the ratio of the Cereal Production (hectares) of Heavily indebted poor countries in 1974 to that in 1977?
Your answer should be very brief. 0.95. What is the ratio of the Cereal Production (hectares) in Morocco in 1974 to that in 1977?
Offer a very short reply. 0.92. What is the ratio of the Cereal Production (hectares) of Sierra Leone in 1974 to that in 1977?
Your answer should be compact. 0.89. What is the ratio of the Cereal Production (hectares) in Heavily indebted poor countries in 1974 to that in 1978?
Ensure brevity in your answer.  0.95. What is the ratio of the Cereal Production (hectares) in Sierra Leone in 1974 to that in 1978?
Offer a very short reply. 0.86. What is the ratio of the Cereal Production (hectares) in Heavily indebted poor countries in 1975 to that in 1976?
Your answer should be very brief. 0.96. What is the ratio of the Cereal Production (hectares) of Morocco in 1975 to that in 1976?
Give a very brief answer. 0.87. What is the ratio of the Cereal Production (hectares) in Sierra Leone in 1975 to that in 1976?
Offer a terse response. 0.94. What is the ratio of the Cereal Production (hectares) of Heavily indebted poor countries in 1975 to that in 1977?
Ensure brevity in your answer.  0.94. What is the ratio of the Cereal Production (hectares) of Morocco in 1975 to that in 1977?
Your response must be concise. 0.85. What is the ratio of the Cereal Production (hectares) of Sierra Leone in 1975 to that in 1977?
Your response must be concise. 0.92. What is the ratio of the Cereal Production (hectares) of Heavily indebted poor countries in 1975 to that in 1978?
Ensure brevity in your answer.  0.94. What is the ratio of the Cereal Production (hectares) in Morocco in 1975 to that in 1978?
Make the answer very short. 0.88. What is the ratio of the Cereal Production (hectares) in Sierra Leone in 1975 to that in 1978?
Make the answer very short. 0.89. What is the ratio of the Cereal Production (hectares) in Heavily indebted poor countries in 1976 to that in 1977?
Your response must be concise. 0.98. What is the ratio of the Cereal Production (hectares) in Morocco in 1976 to that in 1977?
Your response must be concise. 0.97. What is the ratio of the Cereal Production (hectares) in Sierra Leone in 1976 to that in 1977?
Offer a very short reply. 0.98. What is the ratio of the Cereal Production (hectares) in Heavily indebted poor countries in 1976 to that in 1978?
Give a very brief answer. 0.98. What is the ratio of the Cereal Production (hectares) of Morocco in 1976 to that in 1978?
Provide a short and direct response. 1.01. What is the ratio of the Cereal Production (hectares) of Sierra Leone in 1976 to that in 1978?
Offer a terse response. 0.94. What is the ratio of the Cereal Production (hectares) of Heavily indebted poor countries in 1977 to that in 1978?
Give a very brief answer. 1. What is the ratio of the Cereal Production (hectares) of Morocco in 1977 to that in 1978?
Your response must be concise. 1.05. What is the ratio of the Cereal Production (hectares) in Sierra Leone in 1977 to that in 1978?
Give a very brief answer. 0.97. What is the difference between the highest and the second highest Cereal Production (hectares) of Heavily indebted poor countries?
Make the answer very short. 7.14e+04. What is the difference between the highest and the second highest Cereal Production (hectares) of Morocco?
Give a very brief answer. 1.51e+05. What is the difference between the highest and the second highest Cereal Production (hectares) in Sierra Leone?
Give a very brief answer. 1.50e+04. What is the difference between the highest and the lowest Cereal Production (hectares) in Heavily indebted poor countries?
Give a very brief answer. 3.44e+06. What is the difference between the highest and the lowest Cereal Production (hectares) of Morocco?
Offer a terse response. 7.63e+05. What is the difference between the highest and the lowest Cereal Production (hectares) in Sierra Leone?
Give a very brief answer. 8.48e+04. 